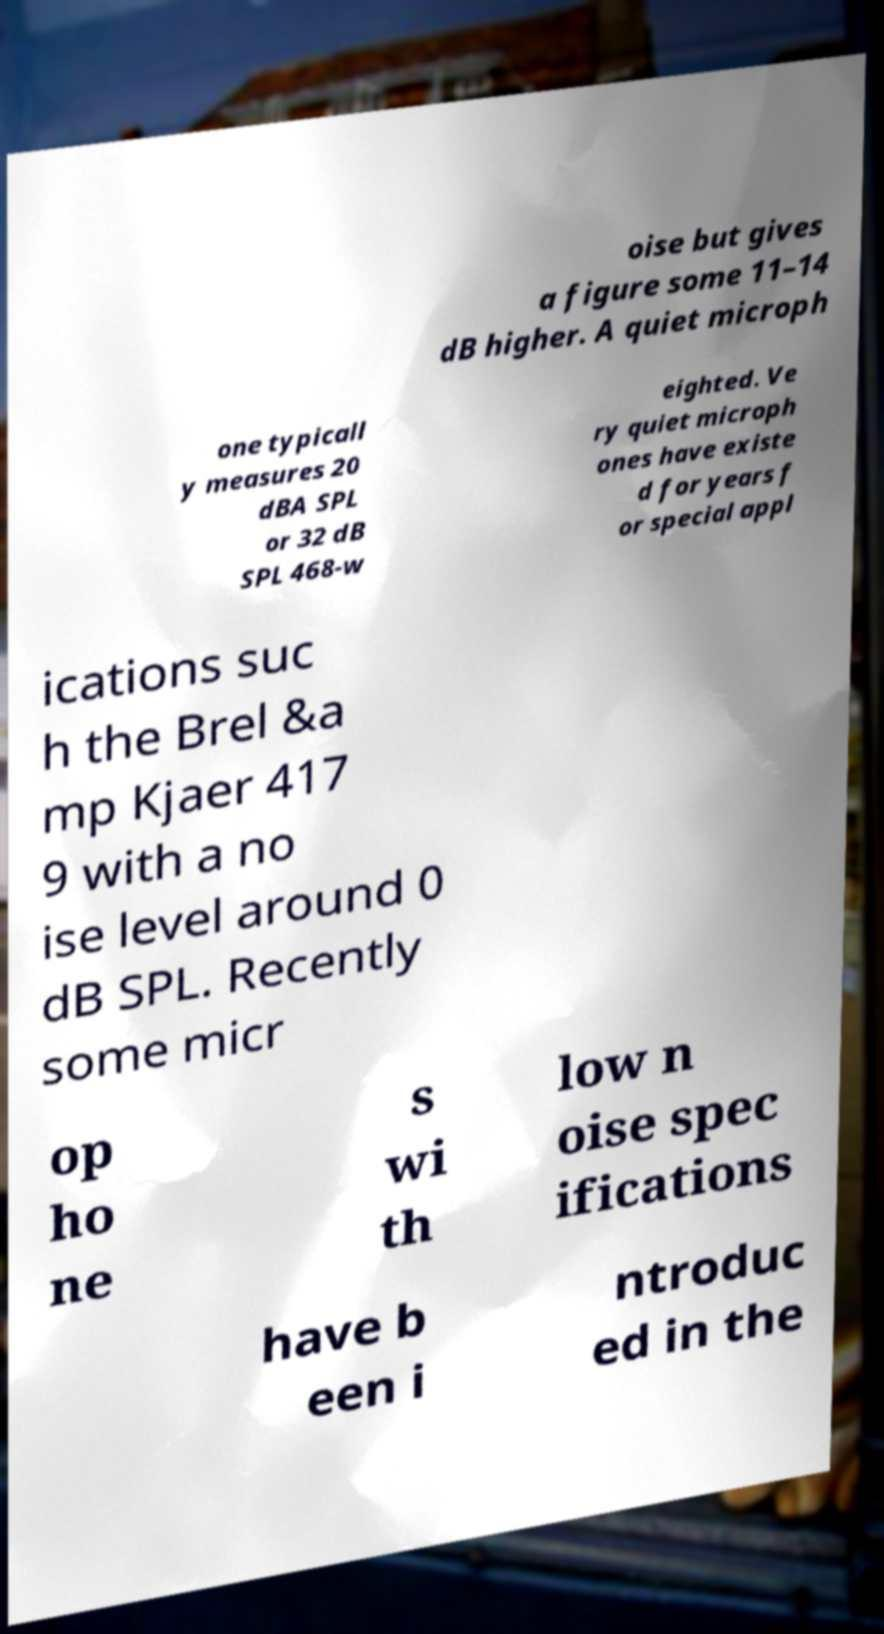Could you extract and type out the text from this image? oise but gives a figure some 11–14 dB higher. A quiet microph one typicall y measures 20 dBA SPL or 32 dB SPL 468-w eighted. Ve ry quiet microph ones have existe d for years f or special appl ications suc h the Brel &a mp Kjaer 417 9 with a no ise level around 0 dB SPL. Recently some micr op ho ne s wi th low n oise spec ifications have b een i ntroduc ed in the 